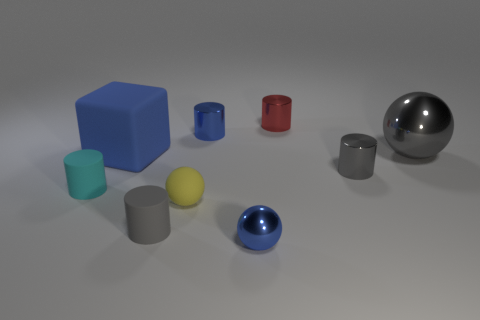How many other objects are there of the same material as the tiny red cylinder?
Your answer should be very brief. 4. How many objects are either blue objects in front of the big blue matte object or gray objects that are left of the big sphere?
Offer a very short reply. 3. What is the material of the tiny cyan thing that is the same shape as the tiny gray metal thing?
Give a very brief answer. Rubber. Are any big cyan matte objects visible?
Offer a terse response. No. What is the size of the metallic object that is both behind the large matte cube and left of the red cylinder?
Make the answer very short. Small. There is a small cyan matte thing; what shape is it?
Your answer should be very brief. Cylinder. Is there a gray matte object behind the thing that is behind the tiny blue shiny cylinder?
Your answer should be very brief. No. What material is the other ball that is the same size as the yellow matte ball?
Give a very brief answer. Metal. Is there a metal ball of the same size as the blue cylinder?
Your answer should be very brief. Yes. There is a tiny ball behind the small gray matte thing; what is it made of?
Your answer should be compact. Rubber. 